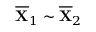Convert formula to latex. <formula><loc_0><loc_0><loc_500><loc_500>\overline { X } _ { 1 } \sim \overline { X } _ { 2 }</formula> 